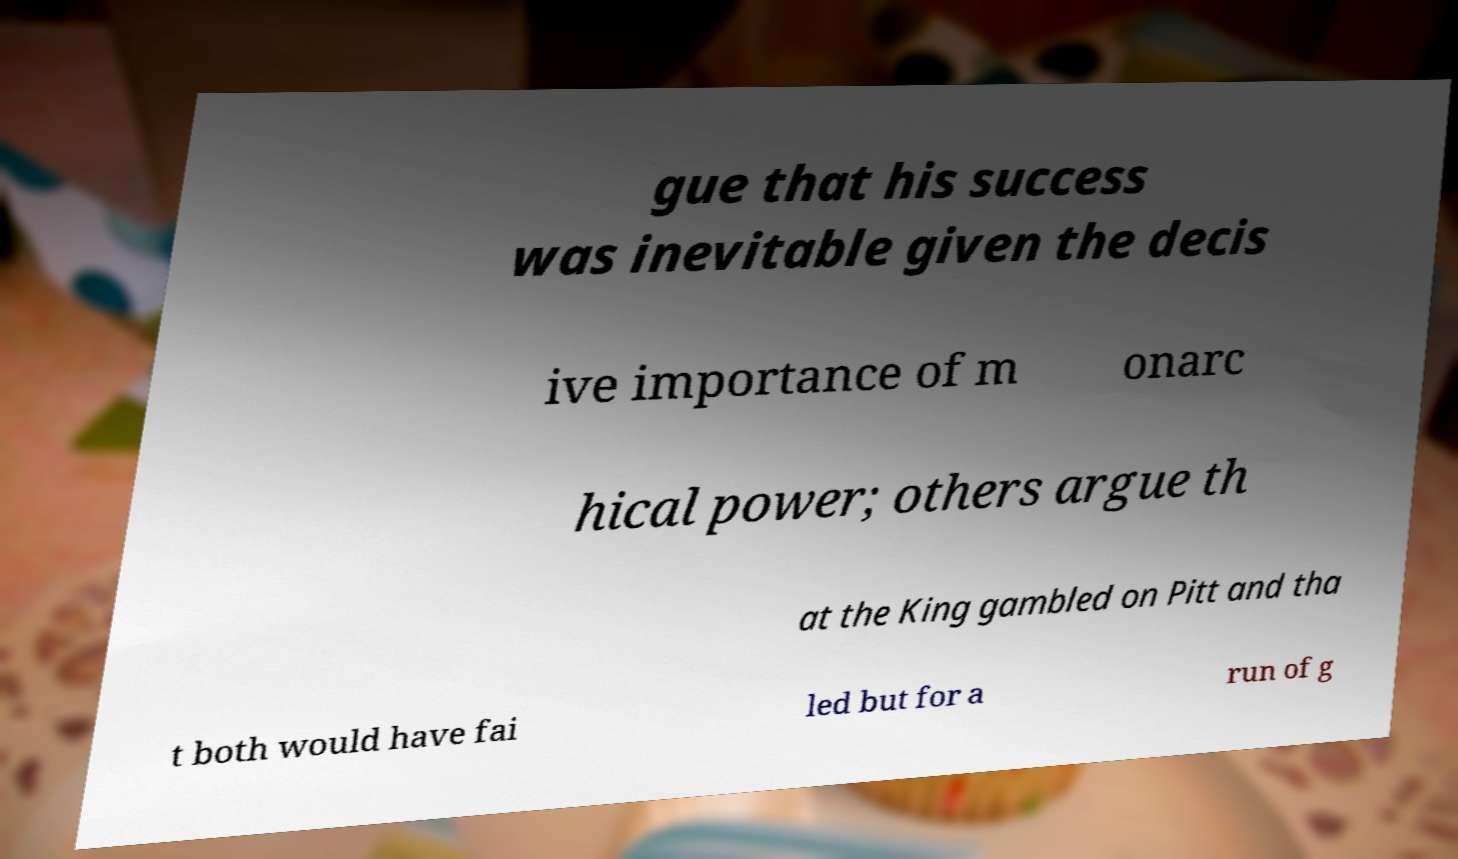Can you read and provide the text displayed in the image?This photo seems to have some interesting text. Can you extract and type it out for me? gue that his success was inevitable given the decis ive importance of m onarc hical power; others argue th at the King gambled on Pitt and tha t both would have fai led but for a run of g 